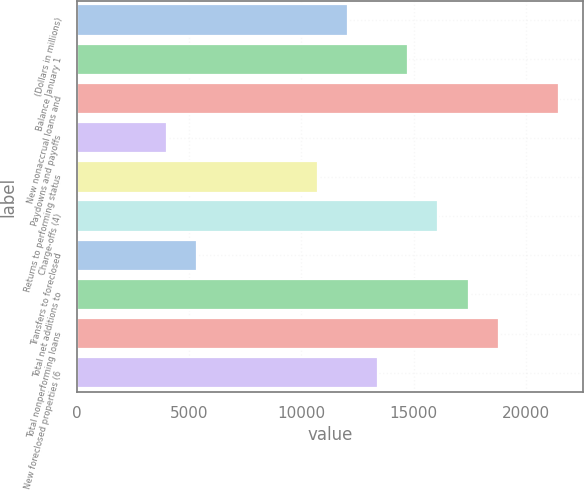Convert chart. <chart><loc_0><loc_0><loc_500><loc_500><bar_chart><fcel>(Dollars in millions)<fcel>Balance January 1<fcel>New nonaccrual loans and<fcel>Paydowns and payoffs<fcel>Returns to performing status<fcel>Charge-offs (4)<fcel>Transfers to foreclosed<fcel>Total net additions to<fcel>Total nonperforming loans<fcel>New foreclosed properties (6<nl><fcel>12079<fcel>14762.9<fcel>21472.6<fcel>4027.47<fcel>10737.1<fcel>16104.8<fcel>5369.4<fcel>17446.8<fcel>18788.7<fcel>13421<nl></chart> 